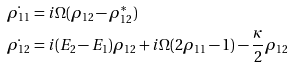<formula> <loc_0><loc_0><loc_500><loc_500>& \dot { \rho _ { 1 1 } } = i \Omega ( \rho _ { 1 2 } - \rho _ { 1 2 } ^ { * } ) \\ & \dot { \rho _ { 1 2 } } = i ( E _ { 2 } - E _ { 1 } ) \rho _ { 1 2 } + i \Omega ( 2 \rho _ { 1 1 } - 1 ) - \frac { \kappa } { 2 } \rho _ { 1 2 }</formula> 